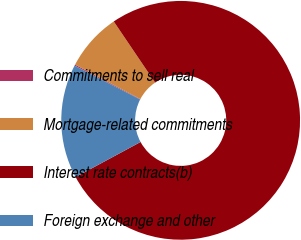Convert chart. <chart><loc_0><loc_0><loc_500><loc_500><pie_chart><fcel>Commitments to sell real<fcel>Mortgage-related commitments<fcel>Interest rate contracts(b)<fcel>Foreign exchange and other<nl><fcel>0.16%<fcel>7.8%<fcel>76.59%<fcel>15.45%<nl></chart> 